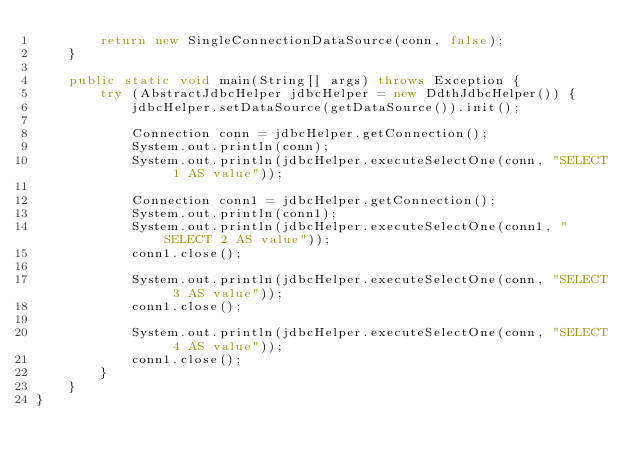<code> <loc_0><loc_0><loc_500><loc_500><_Java_>        return new SingleConnectionDataSource(conn, false);
    }

    public static void main(String[] args) throws Exception {
        try (AbstractJdbcHelper jdbcHelper = new DdthJdbcHelper()) {
            jdbcHelper.setDataSource(getDataSource()).init();

            Connection conn = jdbcHelper.getConnection();
            System.out.println(conn);
            System.out.println(jdbcHelper.executeSelectOne(conn, "SELECT 1 AS value"));

            Connection conn1 = jdbcHelper.getConnection();
            System.out.println(conn1);
            System.out.println(jdbcHelper.executeSelectOne(conn1, "SELECT 2 AS value"));
            conn1.close();

            System.out.println(jdbcHelper.executeSelectOne(conn, "SELECT 3 AS value"));
            conn1.close();

            System.out.println(jdbcHelper.executeSelectOne(conn, "SELECT 4 AS value"));
            conn1.close();
        }
    }
}
</code> 